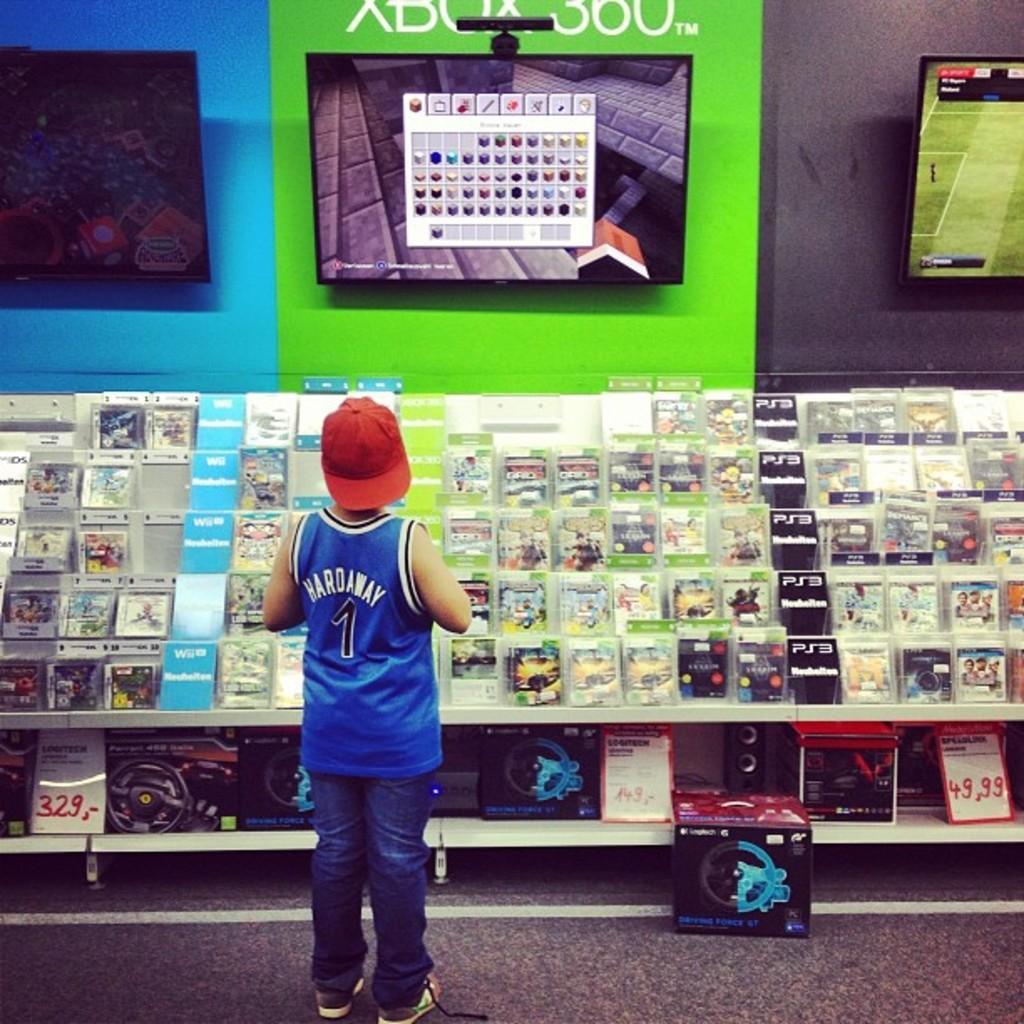Can you describe this image briefly? In this image I can see a boy is standing, I can see he is wearing blue cloth, red cap, blue jeans and shoes. Here I can see something is written on his dress. In the background I can see few screens and I can also see number of things over here. I can also see few boxes on this rack. 